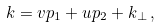<formula> <loc_0><loc_0><loc_500><loc_500>k = v p _ { 1 } + u p _ { 2 } + k _ { \perp } \, ,</formula> 